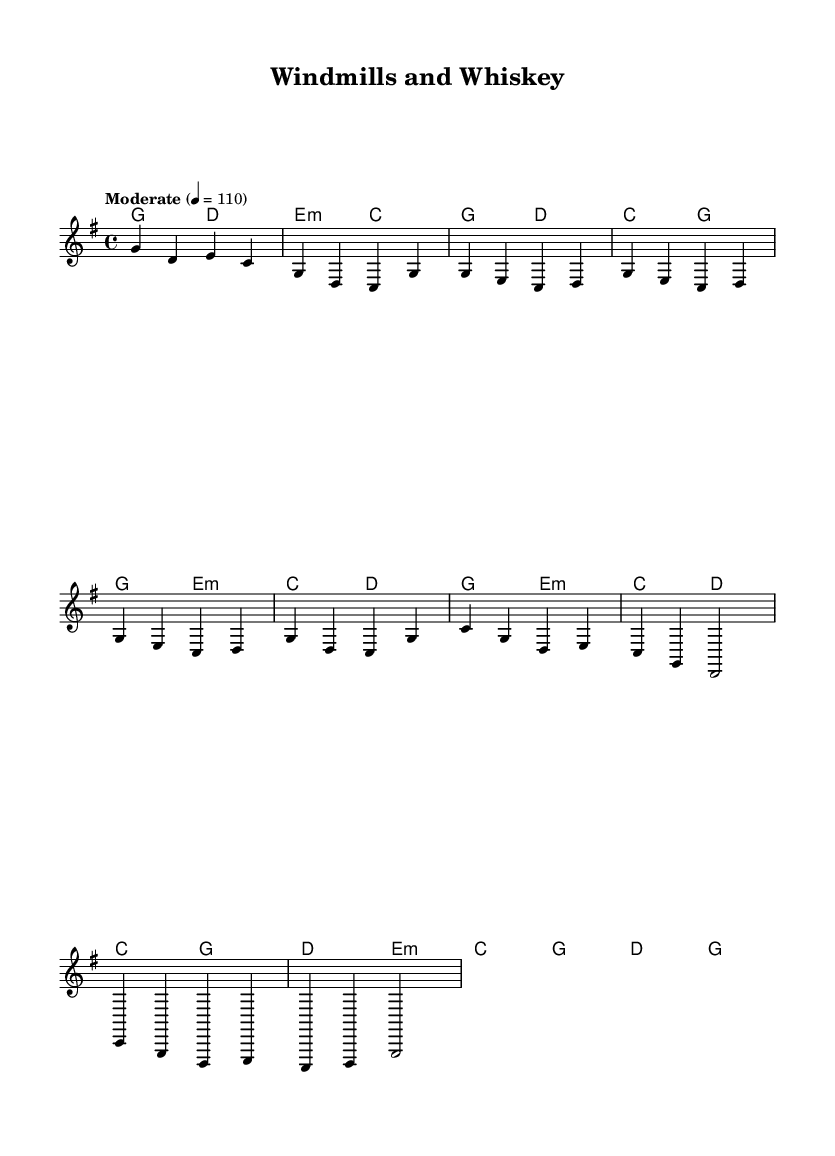What is the key signature of this music? The key signature is G major, which has one sharp (F#). This is indicated at the beginning of the staff.
Answer: G major What is the time signature of this piece? The time signature is four beats per measure, shown in the sheet music as 4/4.
Answer: 4/4 What is the tempo marking for this piece? The tempo is marked as "Moderate" at a speed of 110 beats per minute, which indicates a lively but manageable pace.
Answer: Moderate 4 = 110 How many measures does the introduction contain? The introduction consists of 4 measures, as indicated by the grouping of the notes in the melody section.
Answer: 4 measures Which chord is used in the chorus section? The chords used in the chorus include C, G, D, and E minor. These are repeated throughout the chorus segment.
Answer: C, G, D, E minor What style is this music primarily associated with? This music style blends country and rock influences, particularly through the use of typical chord progressions and instrumentation.
Answer: Country Rock What unique Dutch influence can be identified in this composition? The title "Windmills and Whiskey" suggests a connection to Dutch culture, particularly features like windmills, reflecting a fusion of Dutch themes with country rock.
Answer: Dutch themes 